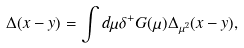Convert formula to latex. <formula><loc_0><loc_0><loc_500><loc_500>\Delta ( x - y ) = \int d \mu \delta ^ { + } G ( \mu ) \Delta _ { \mu ^ { 2 } } ( x - y ) ,</formula> 